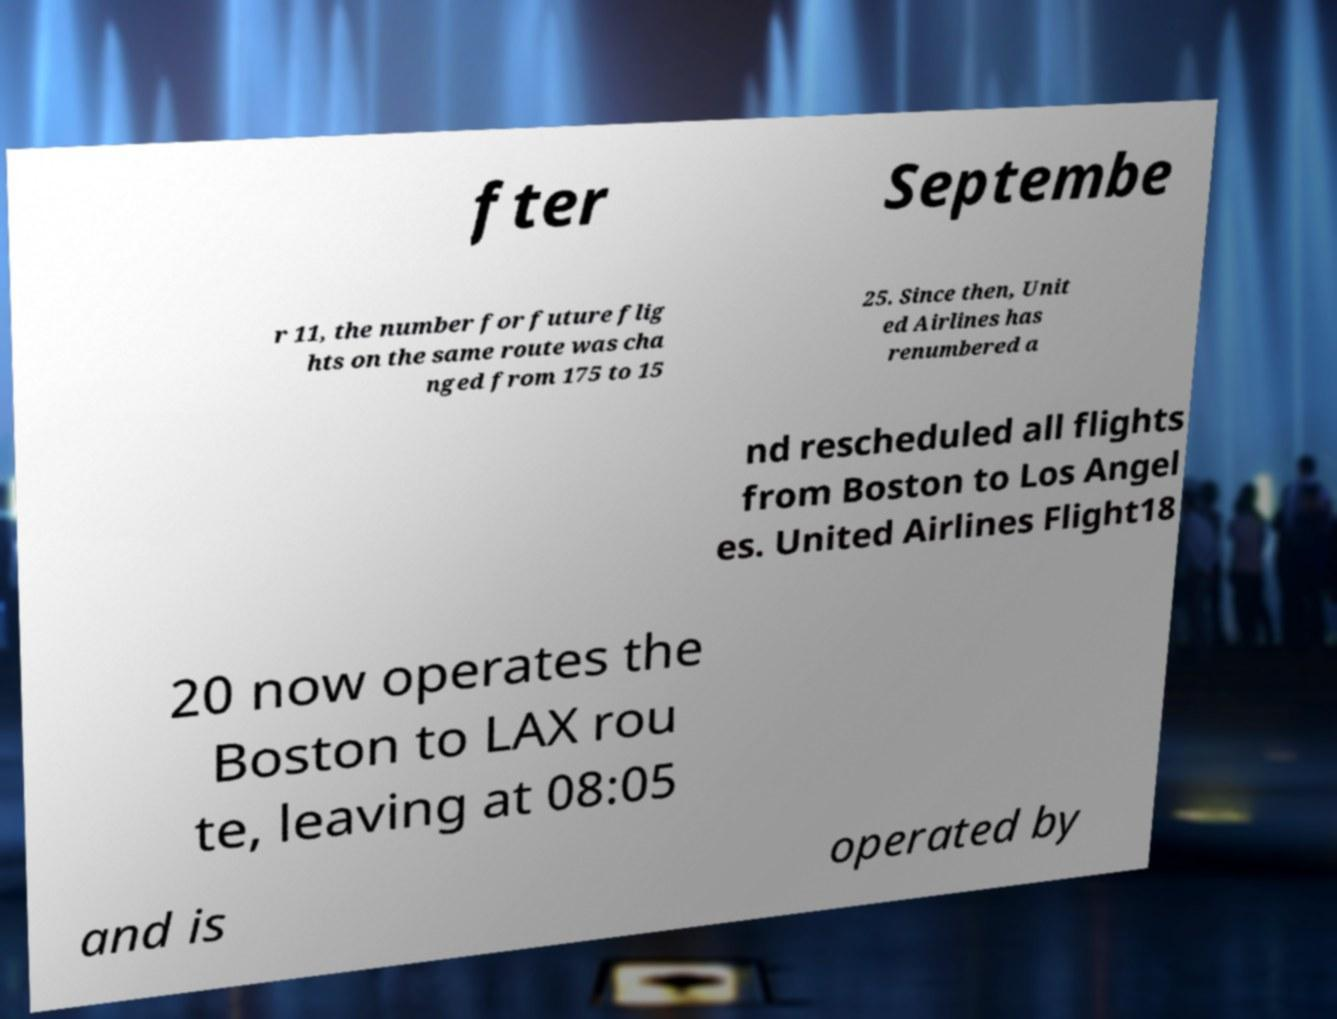Please identify and transcribe the text found in this image. fter Septembe r 11, the number for future flig hts on the same route was cha nged from 175 to 15 25. Since then, Unit ed Airlines has renumbered a nd rescheduled all flights from Boston to Los Angel es. United Airlines Flight18 20 now operates the Boston to LAX rou te, leaving at 08:05 and is operated by 